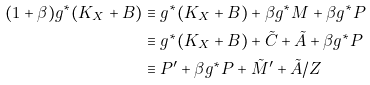<formula> <loc_0><loc_0><loc_500><loc_500>( 1 + \beta ) g ^ { * } ( K _ { X } + B ) & \equiv g ^ { * } ( K _ { X } + B ) + \beta g ^ { * } M + \beta g ^ { * } P \\ & \equiv g ^ { * } ( K _ { X } + B ) + \tilde { C } + \tilde { A } + \beta g ^ { * } P \\ & \equiv P ^ { \prime } + \beta g ^ { * } P + \tilde { M } ^ { \prime } + \tilde { A } / Z</formula> 